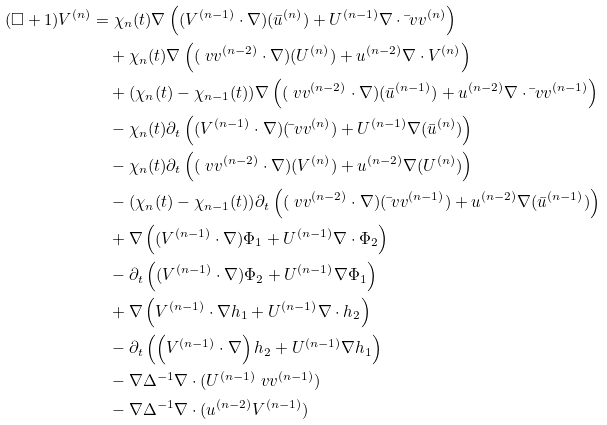<formula> <loc_0><loc_0><loc_500><loc_500>( \square + 1 ) V ^ { ( n ) } & = \chi _ { n } ( t ) \nabla \left ( ( V ^ { ( n - 1 ) } \cdot \nabla ) ( \bar { u } ^ { ( n ) } ) + U ^ { ( n - 1 ) } \nabla \cdot \bar { \ } v v ^ { ( n ) } \right ) \\ & \quad + \chi _ { n } ( t ) \nabla \left ( ( \ v v ^ { ( n - 2 ) } \cdot \nabla ) ( U ^ { ( n ) } ) + u ^ { ( n - 2 ) } \nabla \cdot V ^ { ( n ) } \right ) \\ & \quad + ( \chi _ { n } ( t ) - \chi _ { n - 1 } ( t ) ) \nabla \left ( ( \ v v ^ { ( n - 2 ) } \cdot \nabla ) ( \bar { u } ^ { ( n - 1 ) } ) + u ^ { ( n - 2 ) } \nabla \cdot \bar { \ } v v ^ { ( n - 1 ) } \right ) \\ & \quad - \chi _ { n } ( t ) \partial _ { t } \left ( ( V ^ { ( n - 1 ) } \cdot \nabla ) ( \bar { \ } v v ^ { ( n ) } ) + U ^ { ( n - 1 ) } \nabla ( \bar { u } ^ { ( n ) } ) \right ) \\ & \quad - \chi _ { n } ( t ) \partial _ { t } \left ( ( \ v v ^ { ( n - 2 ) } \cdot \nabla ) ( V ^ { ( n ) } ) + u ^ { ( n - 2 ) } \nabla ( U ^ { ( n ) } ) \right ) \\ & \quad - ( \chi _ { n } ( t ) - \chi _ { n - 1 } ( t ) ) \partial _ { t } \left ( ( \ v v ^ { ( n - 2 ) } \cdot \nabla ) ( \bar { \ } v v ^ { ( n - 1 ) } ) + u ^ { ( n - 2 ) } \nabla ( \bar { u } ^ { ( n - 1 ) } ) \right ) \\ & \quad + \nabla \left ( ( V ^ { ( n - 1 ) } \cdot \nabla ) \Phi _ { 1 } + U ^ { ( n - 1 ) } \nabla \cdot \Phi _ { 2 } \right ) \\ & \quad - \partial _ { t } \left ( ( V ^ { ( n - 1 ) } \cdot \nabla ) \Phi _ { 2 } + U ^ { ( n - 1 ) } \nabla \Phi _ { 1 } \right ) \\ & \quad + \nabla \left ( V ^ { ( n - 1 ) } \cdot \nabla h _ { 1 } + U ^ { ( n - 1 ) } \nabla \cdot h _ { 2 } \right ) \\ & \quad - \partial _ { t } \left ( \left ( V ^ { ( n - 1 ) } \cdot \nabla \right ) h _ { 2 } + U ^ { ( n - 1 ) } \nabla h _ { 1 } \right ) \\ & \quad - \nabla \Delta ^ { - 1 } \nabla \cdot ( U ^ { ( n - 1 ) } \ v v ^ { ( n - 1 ) } ) \\ & \quad - \nabla \Delta ^ { - 1 } \nabla \cdot ( u ^ { ( n - 2 ) } V ^ { ( n - 1 ) } )</formula> 